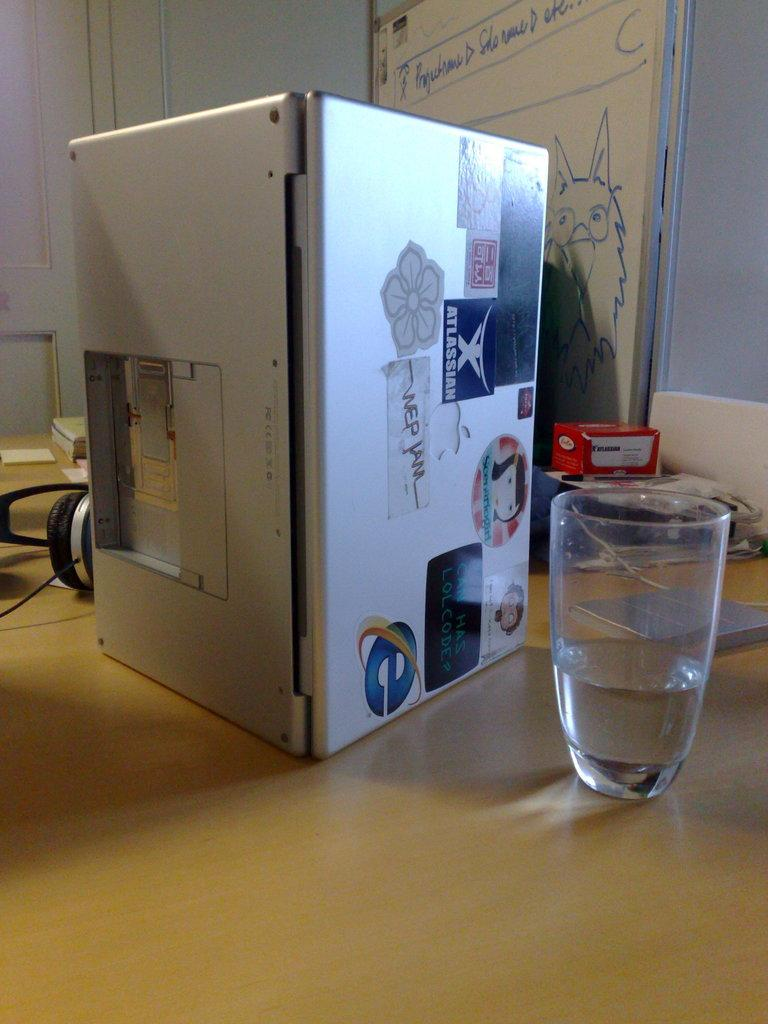<image>
Create a compact narrative representing the image presented. A laptop with numerous stickers on the lid, one of which says Atlassian, is standing up on its side, vertically, on a table, by a glass of water. 